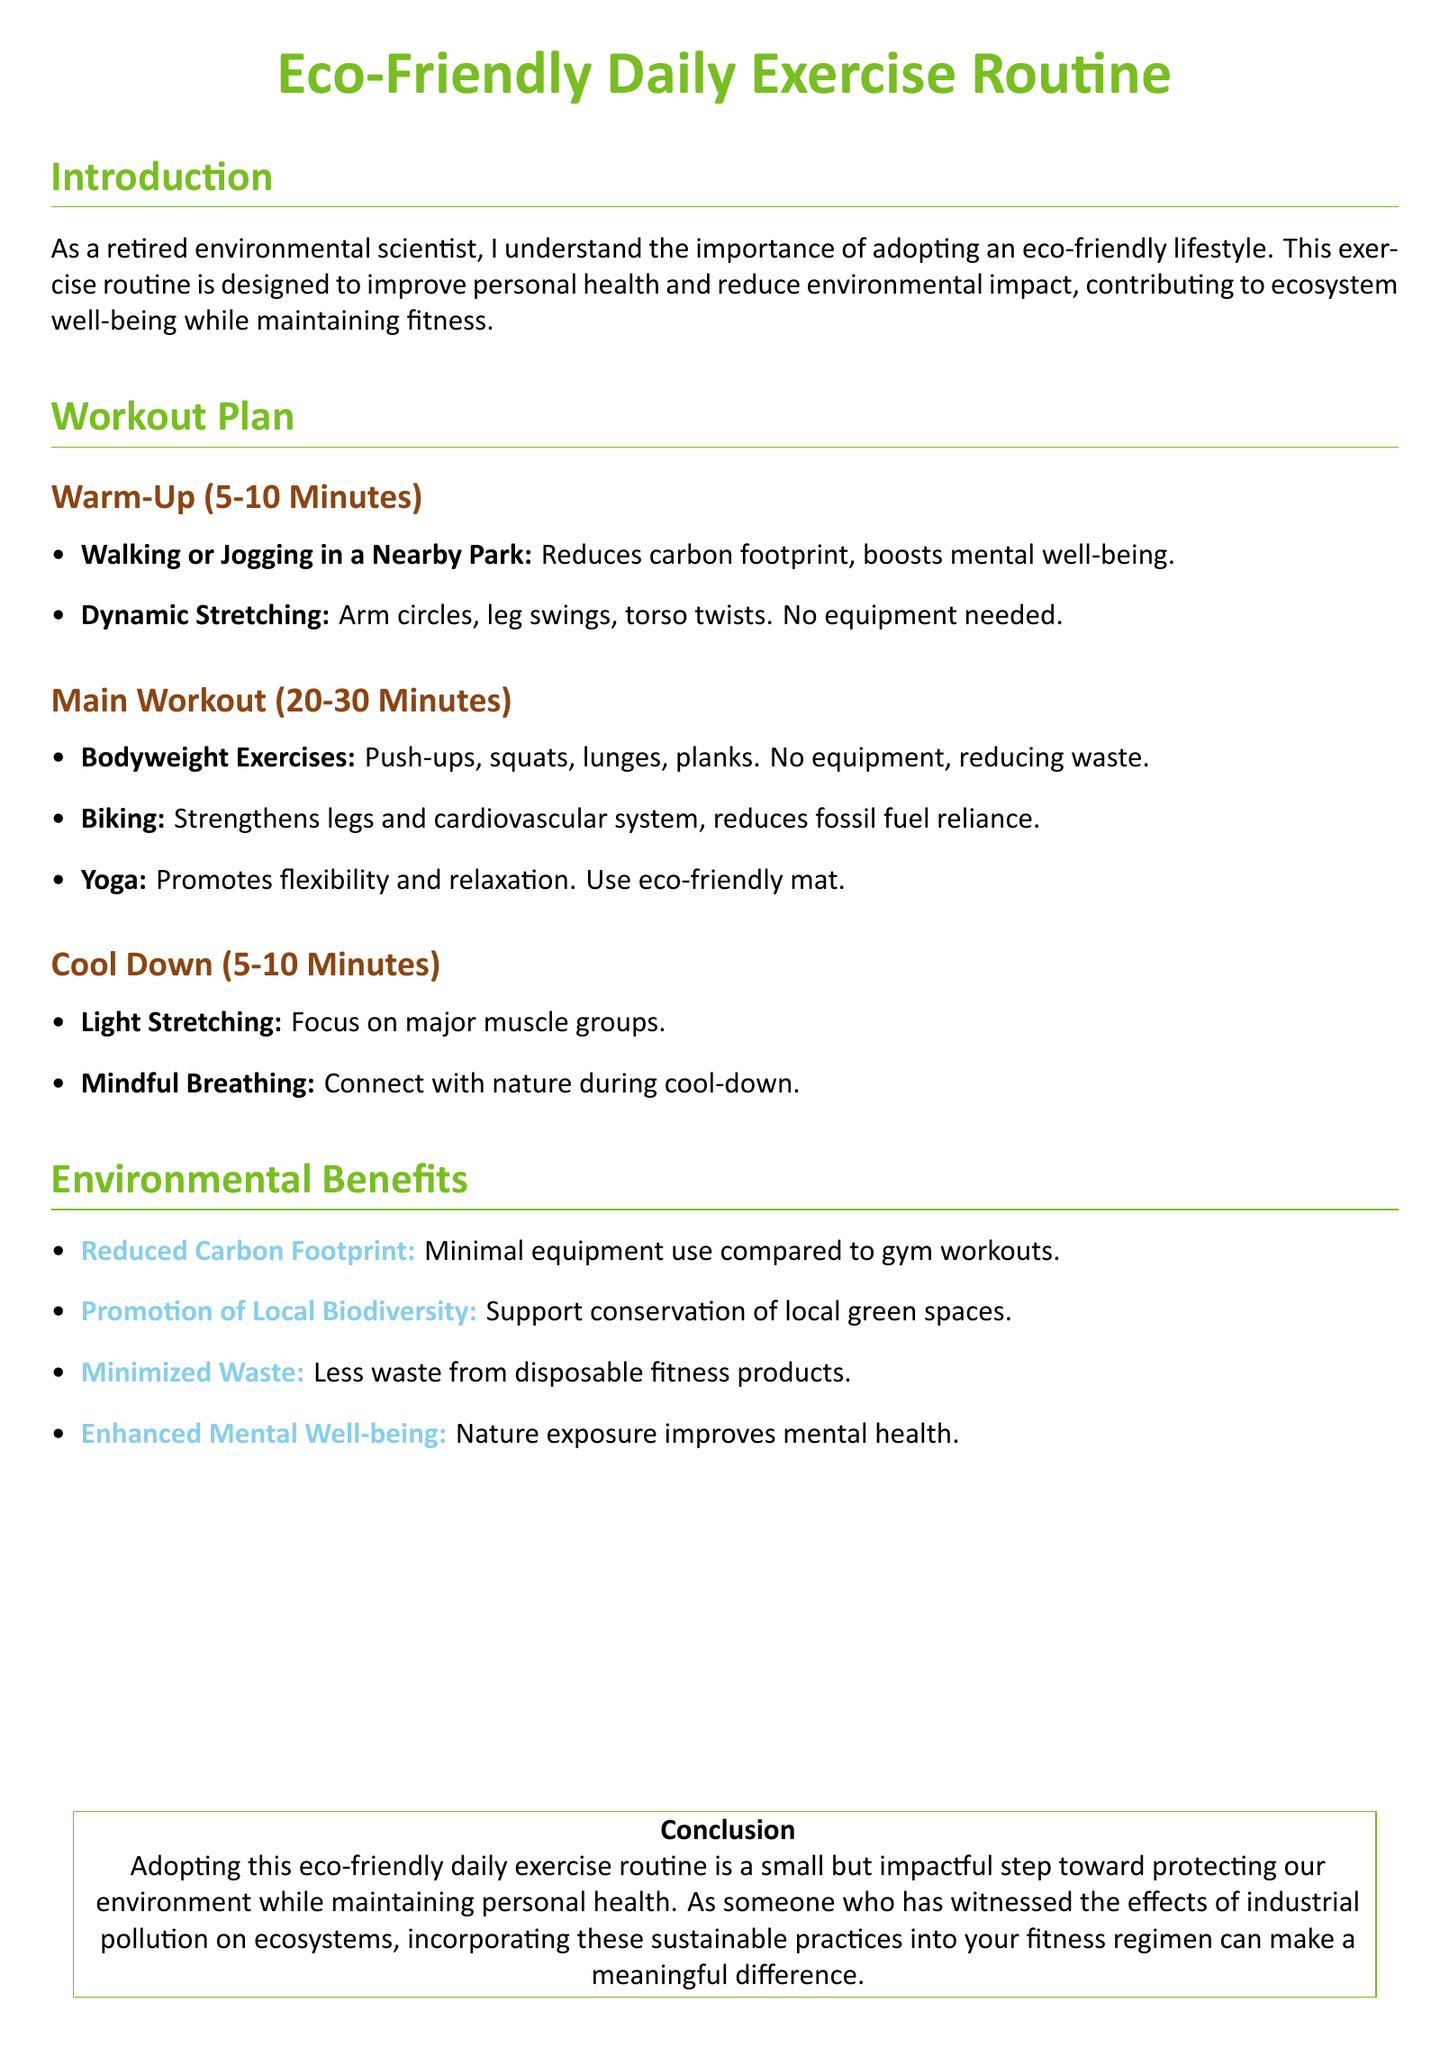What is the duration of the warm-up? The warm-up is specified to last for 5-10 minutes in the document.
Answer: 5-10 minutes What type of exercises are included in the main workout? The main workout includes bodyweight exercises, biking, and yoga as specified in the document.
Answer: Bodyweight exercises, biking, yoga What is the purpose of mindful breathing in the cool down? Mindful breathing is designed to connect with nature during the cool-down period.
Answer: Connect with nature How does biking benefit the environment? Biking reduces fossil fuel reliance, contributing to environmental sustainability.
Answer: Reduces fossil fuel reliance What is one key environmental benefit mentioned? The document highlights reduced carbon footprint as a major environmental benefit of the workout plan.
Answer: Reduced carbon footprint What are two warm-up activities listed? The document includes walking or jogging in a nearby park and dynamic stretching as warm-up activities.
Answer: Walking or jogging, dynamic stretching How does nature exposure impact mental health? Nature exposure is stated to improve mental well-being, as mentioned in the environmental benefits section.
Answer: Improves mental well-being What type of mat is suggested for yoga? The document suggests using an eco-friendly mat for yoga practice.
Answer: Eco-friendly mat 